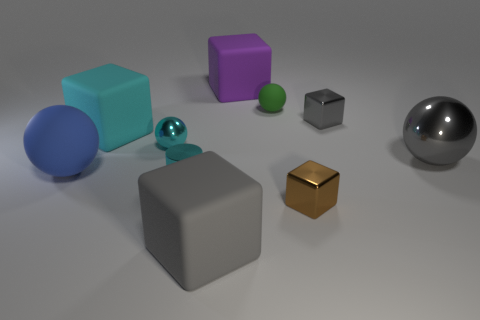Subtract all purple cubes. How many cubes are left? 4 Subtract all brown cubes. How many cubes are left? 4 Subtract 5 blocks. How many blocks are left? 0 Subtract all cylinders. How many objects are left? 9 Subtract 2 gray cubes. How many objects are left? 8 Subtract all green blocks. Subtract all green spheres. How many blocks are left? 5 Subtract all purple cylinders. How many blue cubes are left? 0 Subtract all large brown rubber spheres. Subtract all large blue rubber spheres. How many objects are left? 9 Add 5 large cyan objects. How many large cyan objects are left? 6 Add 7 small gray things. How many small gray things exist? 8 